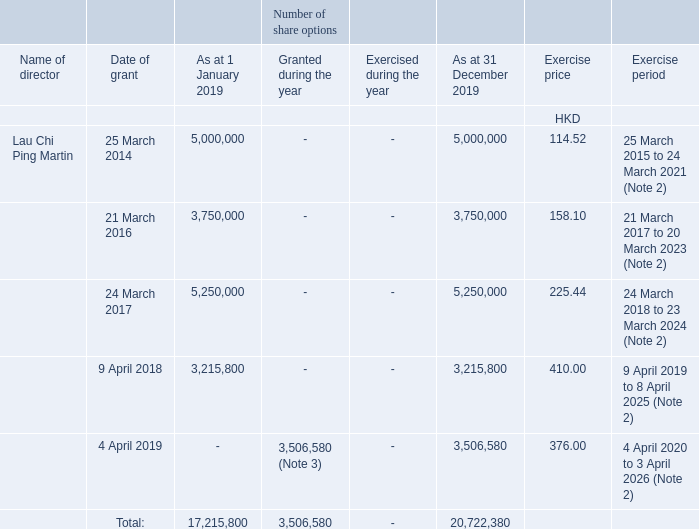The Company has adopted five share option schemes, namely, the Pre-IPO Option Scheme, the Post-IPO Option Scheme I, the Post-IPO Option Scheme II, the Post-IPO Option Scheme III and the Post-IPO Option Scheme IV. The Pre-IPO Option Scheme, the Post-IPO Option Scheme I, the Post-IPO Option Scheme II and the Post-IPO Option Scheme III expired on 31 December 2011, 23 March 2014, 16 May 2017 and 13 May 2019 respectively.
As at 31 December 2019, there were a total of 20,722,380 outstanding share options granted to a director of the Company, details of which are as follows:
1. For options granted with exercisable date determined based on the grant date of options, the first 20% of the total options can be exercised 1 year after the grant date, and each 20% of the total options will become exercisable in each subsequent year.
2. For options granted with exercisable date determined based on the grant date of options, the first 25% of the total options can be exercised 1 year after the grant date, and each 25% of the total options will become exercisable in each subsequent year.
3. The closing price immediately before the date on which the options were granted on 4 April 2019 was HKD378.
4. No options were cancelled or lapsed during the year.
How many share option schemes has the Company adopted? Five. When did the Pre-IPO Option Scheme expire? 31 december 2011. When did the Post-IPO Option Scheme III expire? 13 may 2019. How many percent of the total shares granted as at 1 January was the 25 March 2014 grant?
Answer scale should be: percent. 5,000,000/17,215,800
Answer: 29.04. How many percent of the total shares granted as at 1 January was the 21 March 2016 grant?
Answer scale should be: percent. 3,750,000/17,215,800
Answer: 21.78. How many percent of the total shares granted as at 1 January was the 9 April 2018 grant?
Answer scale should be: percent. 3,215,800/17,215,800
Answer: 18.68. 